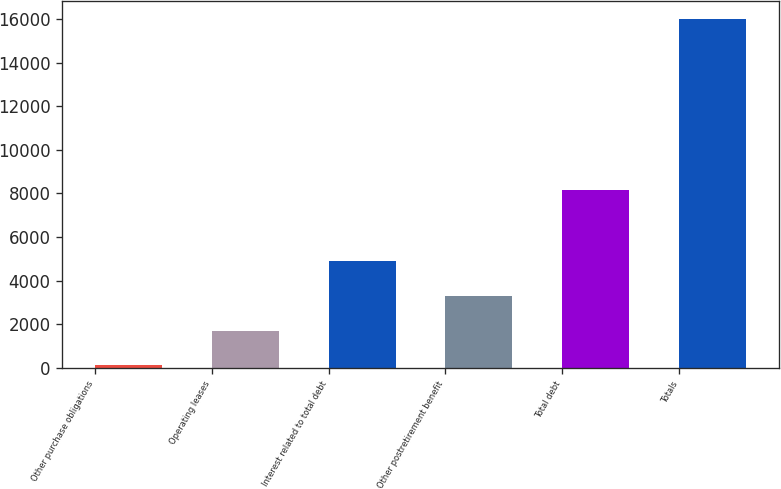Convert chart. <chart><loc_0><loc_0><loc_500><loc_500><bar_chart><fcel>Other purchase obligations<fcel>Operating leases<fcel>Interest related to total debt<fcel>Other postretirement benefit<fcel>Total debt<fcel>Totals<nl><fcel>119<fcel>1709<fcel>4889<fcel>3299<fcel>8137<fcel>16019<nl></chart> 